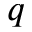<formula> <loc_0><loc_0><loc_500><loc_500>q</formula> 